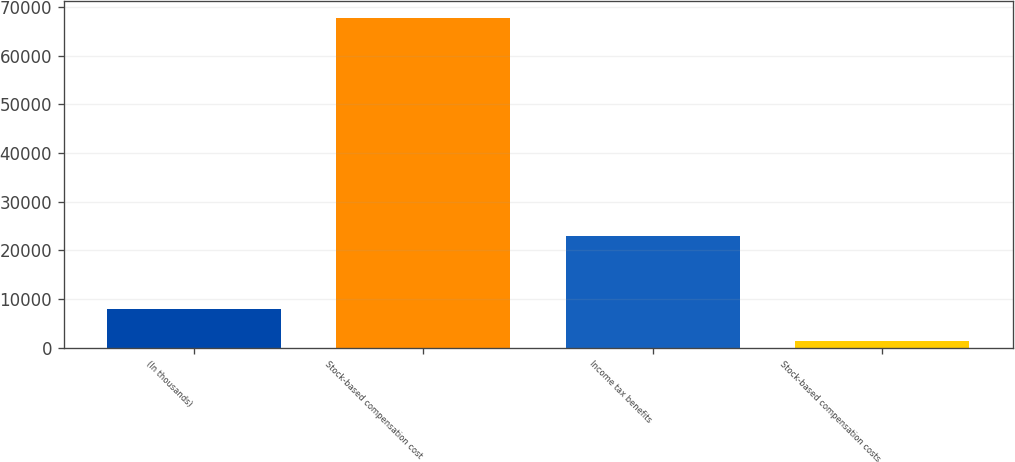Convert chart. <chart><loc_0><loc_0><loc_500><loc_500><bar_chart><fcel>(In thousands)<fcel>Stock-based compensation cost<fcel>Income tax benefits<fcel>Stock-based compensation costs<nl><fcel>7975<fcel>67762<fcel>22870<fcel>1332<nl></chart> 